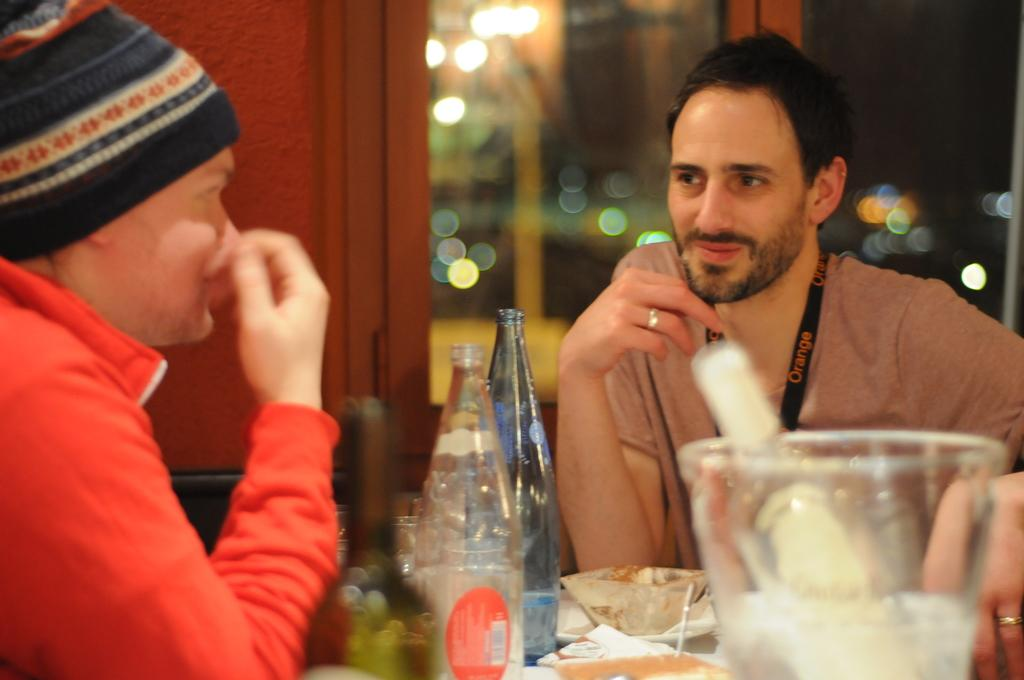How many people are in the image? There are two people in the image. What are the people doing in the image? The people are sitting in front of a table. What can be seen on the table in the image? There is a jar, bottles, and other unspecified things on the table. Is there any entrance visible in the image? Yes, there is a door visible in the image. What can be seen in terms of lighting in the image? There are lights in the image. How many centimeters long is the toad sitting on the table in the image? There is no toad present in the image, so it is not possible to determine its length. What type of ring can be seen on the finger of one of the people in the image? There is no ring visible on the fingers of the people in the image. 